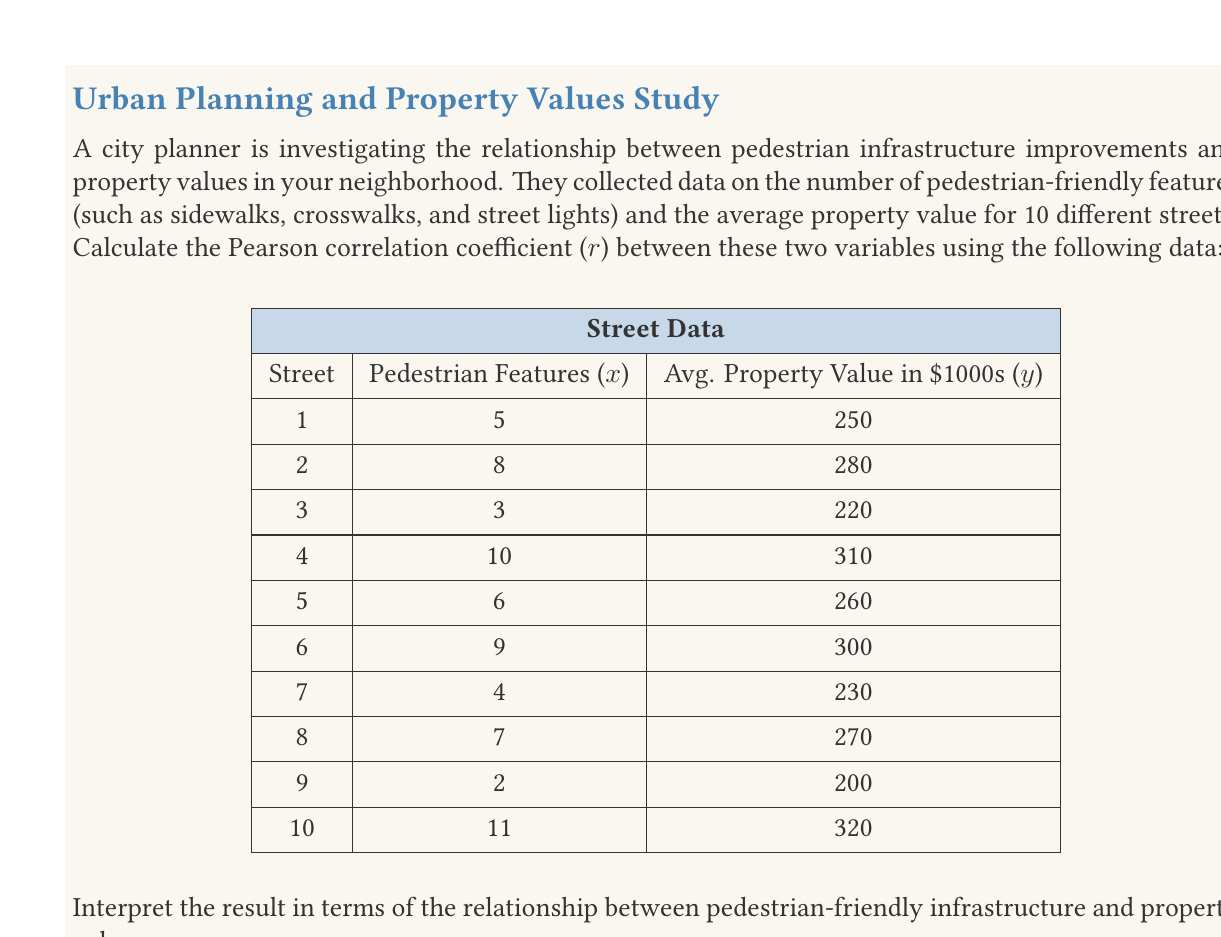Show me your answer to this math problem. To calculate the Pearson correlation coefficient (r), we'll use the formula:

$$ r = \frac{n\sum xy - \sum x \sum y}{\sqrt{[n\sum x^2 - (\sum x)^2][n\sum y^2 - (\sum y)^2]}} $$

Where:
n = number of pairs of data
x = pedestrian features
y = average property value in $1000s

Step 1: Calculate the sums and squared sums:
$\sum x = 65$
$\sum y = 2640$
$\sum xy = 17,860$
$\sum x^2 = 497$
$\sum y^2 = 709,400$

Step 2: Substitute these values into the formula:

$$ r = \frac{10(17,860) - (65)(2640)}{\sqrt{[10(497) - 65^2][10(709,400) - 2640^2]}} $$

Step 3: Simplify:

$$ r = \frac{178,600 - 171,600}{\sqrt{(4970 - 4225)(7,094,000 - 6,969,600)}} $$

$$ r = \frac{7000}{\sqrt{(745)(124,400)}} $$

$$ r = \frac{7000}{\sqrt{92,678,000}} $$

$$ r = \frac{7000}{9628.50} $$

$$ r \approx 0.7270 $$

Interpretation: The Pearson correlation coefficient of approximately 0.7270 indicates a strong positive correlation between the number of pedestrian-friendly features and average property values. This suggests that as the number of pedestrian-friendly features increases, property values tend to increase as well. This correlation supports the idea that pedestrian-friendly infrastructure can enhance the quality of life in a neighborhood and potentially increase property values.
Answer: $r \approx 0.7270$, indicating a strong positive correlation between pedestrian-friendly features and property values. 